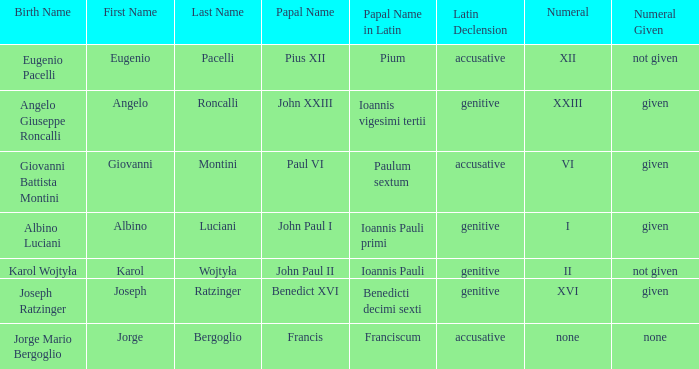For Pope Paul VI, what is the declension of his papal name? Accusative. 